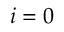Convert formula to latex. <formula><loc_0><loc_0><loc_500><loc_500>\ { i = 0 }</formula> 